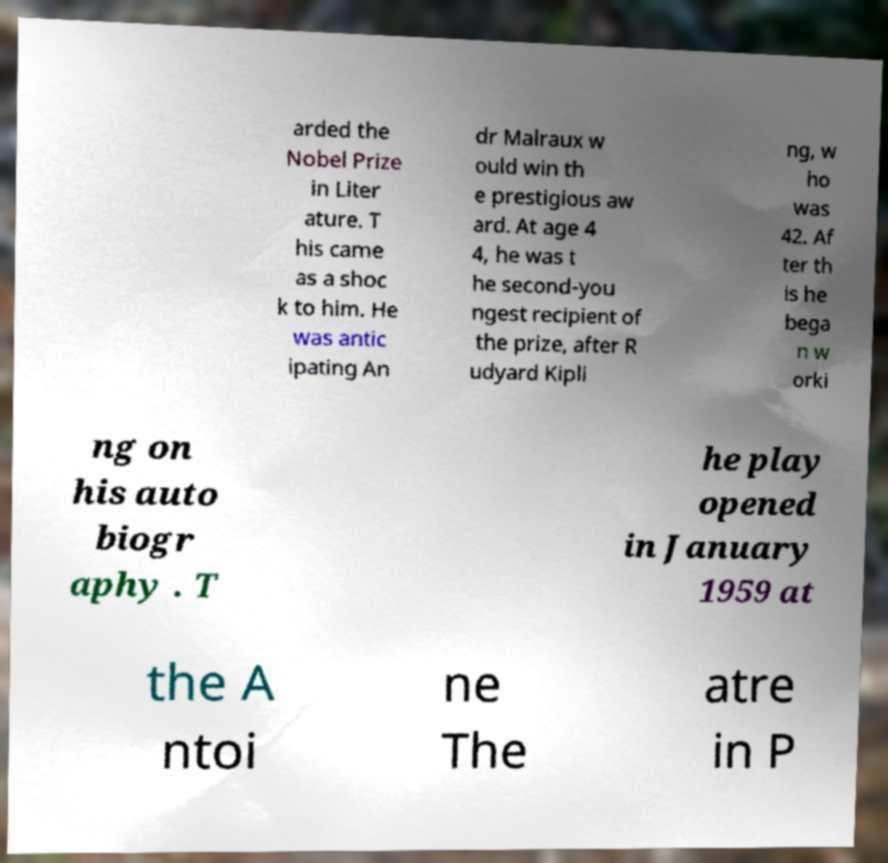For documentation purposes, I need the text within this image transcribed. Could you provide that? arded the Nobel Prize in Liter ature. T his came as a shoc k to him. He was antic ipating An dr Malraux w ould win th e prestigious aw ard. At age 4 4, he was t he second-you ngest recipient of the prize, after R udyard Kipli ng, w ho was 42. Af ter th is he bega n w orki ng on his auto biogr aphy . T he play opened in January 1959 at the A ntoi ne The atre in P 